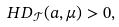<formula> <loc_0><loc_0><loc_500><loc_500>H D _ { \mathcal { T } } ( a , \mu ) > 0 ,</formula> 